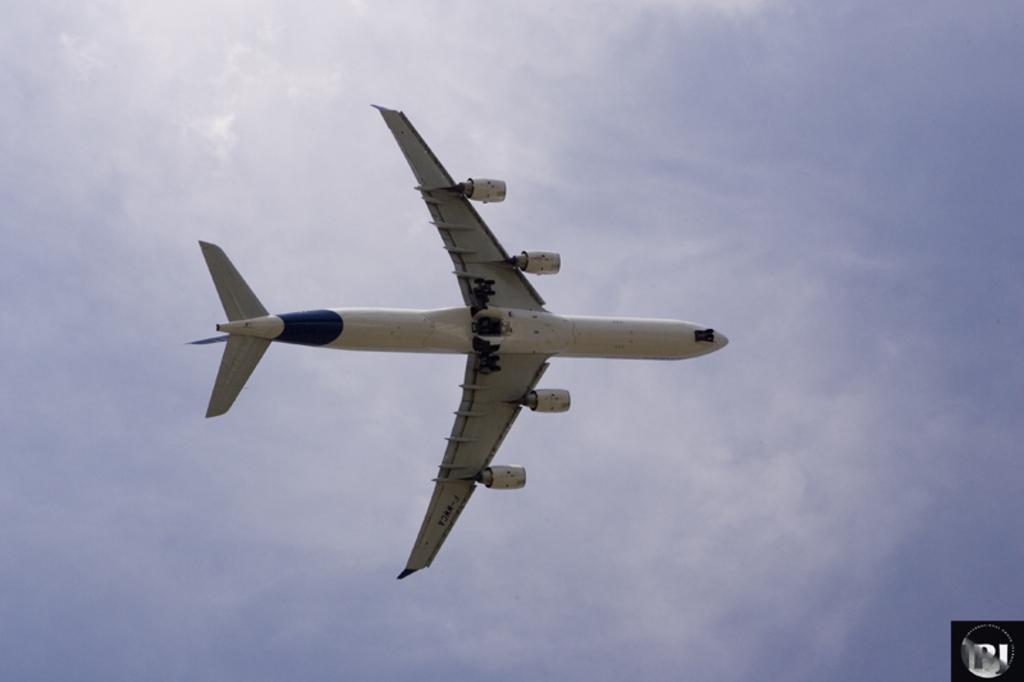Describe this image in one or two sentences. There is an aeroplane in the air. In the background there is sky. 